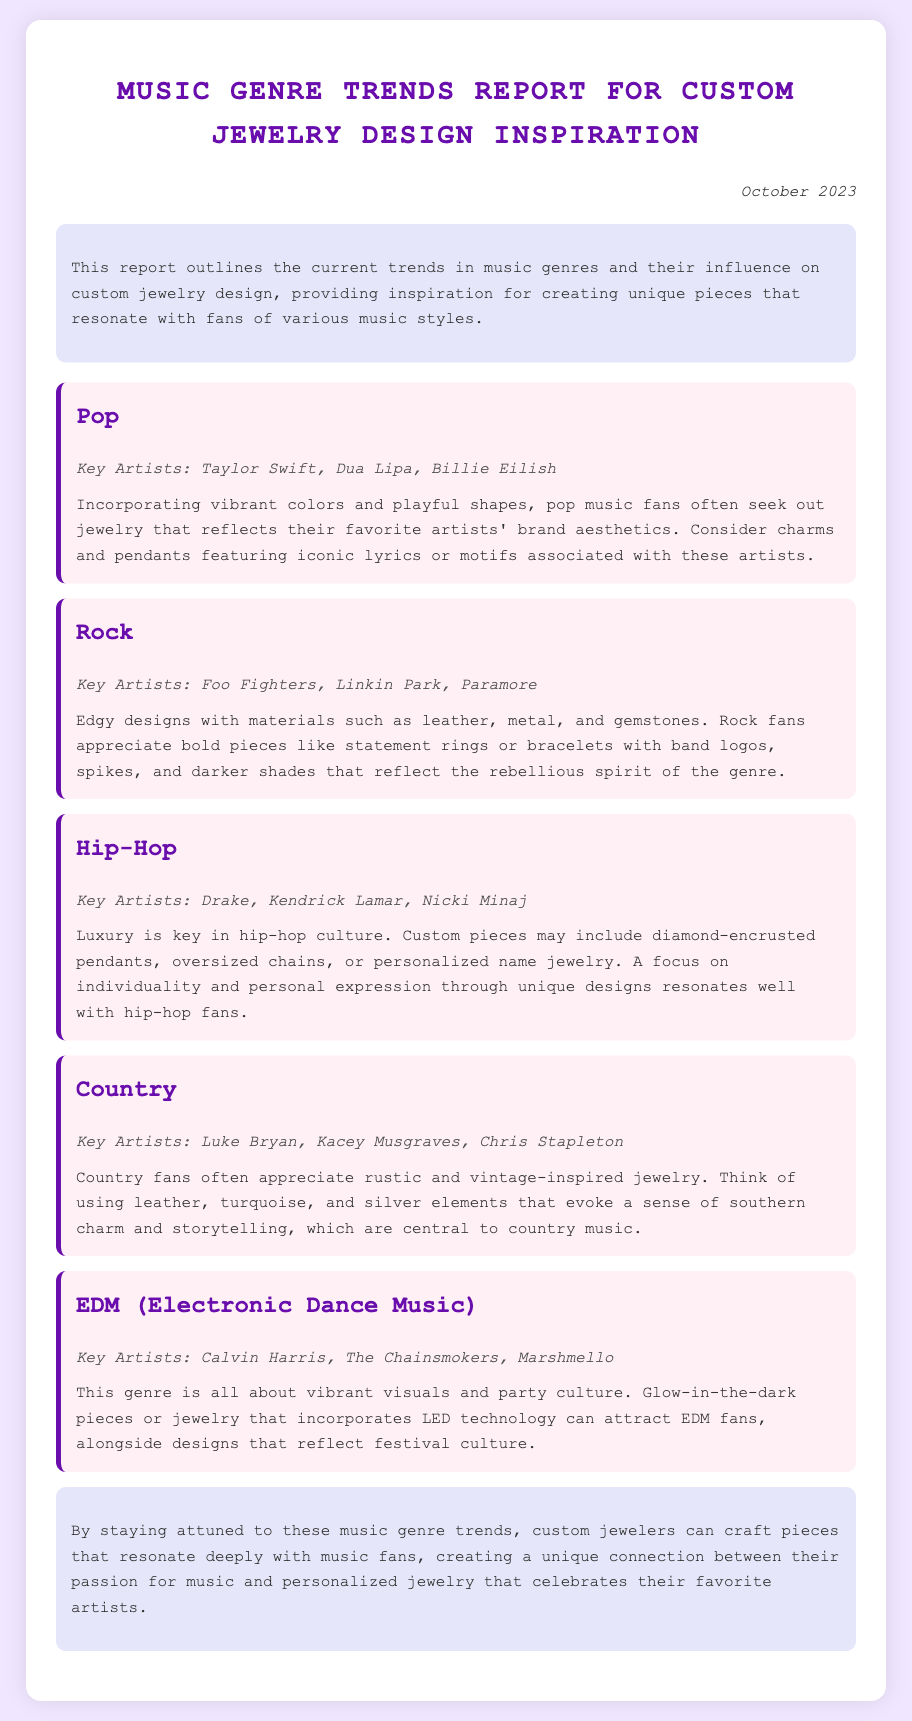What is the date of the report? The date of the report is mentioned at the top right corner of the document.
Answer: October 2023 Which genre includes artists like Taylor Swift? The genre is listed as a heading above the artist names in the report.
Answer: Pop What materials are suggested for rock-inspired jewelry? The materials are mentioned in the description of the rock genre trend.
Answer: Leather, metal, and gemstones Who are key artists of the hip-hop genre? The key artists are noted under the hip-hop genre heading in the trends section.
Answer: Drake, Kendrick Lamar, Nicki Minaj What type of jewelry design is recommended for EDM fans? The suggested design is found in the EDM trend's inspirational description.
Answer: Glow-in-the-dark pieces or jewelry that incorporates LED technology Which music genre focuses on rustic and vintage-inspired jewelry? This information can be found in the country music trend section.
Answer: Country What is the primary aesthetic sought after by pop music fans? The aesthetic is described in the inspiration section for the pop trend.
Answer: Vibrant colors and playful shapes Which genre emphasizes luxury in its jewelry designs? The emphasis on luxury is specifically mentioned in the hip-hop genre section.
Answer: Hip-Hop 